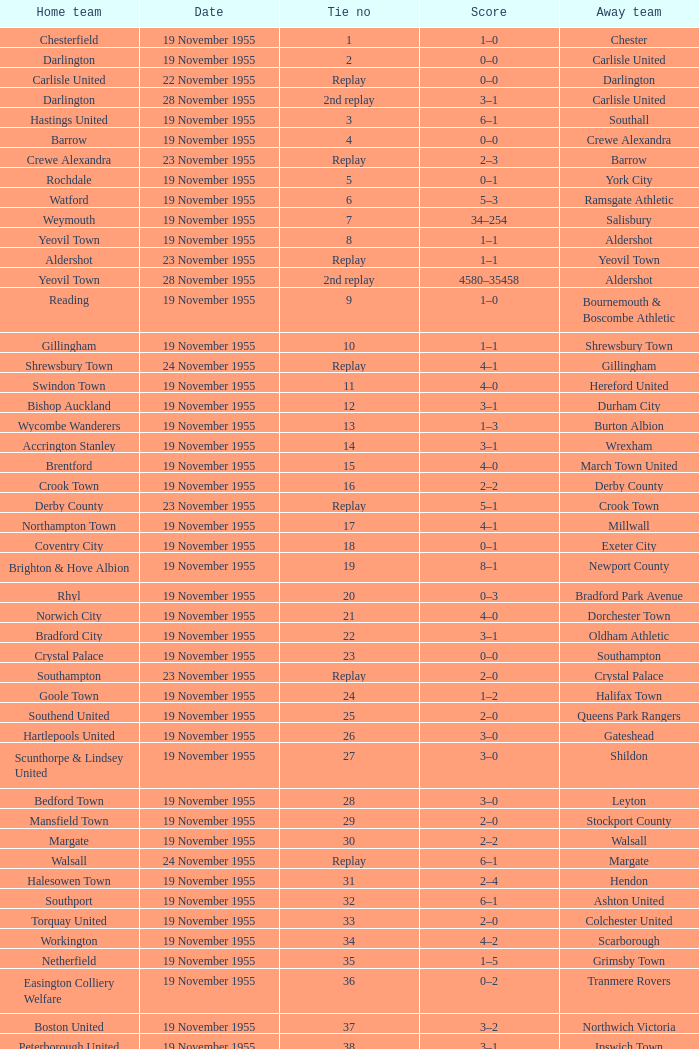Can you parse all the data within this table? {'header': ['Home team', 'Date', 'Tie no', 'Score', 'Away team'], 'rows': [['Chesterfield', '19 November 1955', '1', '1–0', 'Chester'], ['Darlington', '19 November 1955', '2', '0–0', 'Carlisle United'], ['Carlisle United', '22 November 1955', 'Replay', '0–0', 'Darlington'], ['Darlington', '28 November 1955', '2nd replay', '3–1', 'Carlisle United'], ['Hastings United', '19 November 1955', '3', '6–1', 'Southall'], ['Barrow', '19 November 1955', '4', '0–0', 'Crewe Alexandra'], ['Crewe Alexandra', '23 November 1955', 'Replay', '2–3', 'Barrow'], ['Rochdale', '19 November 1955', '5', '0–1', 'York City'], ['Watford', '19 November 1955', '6', '5–3', 'Ramsgate Athletic'], ['Weymouth', '19 November 1955', '7', '34–254', 'Salisbury'], ['Yeovil Town', '19 November 1955', '8', '1–1', 'Aldershot'], ['Aldershot', '23 November 1955', 'Replay', '1–1', 'Yeovil Town'], ['Yeovil Town', '28 November 1955', '2nd replay', '4580–35458', 'Aldershot'], ['Reading', '19 November 1955', '9', '1–0', 'Bournemouth & Boscombe Athletic'], ['Gillingham', '19 November 1955', '10', '1–1', 'Shrewsbury Town'], ['Shrewsbury Town', '24 November 1955', 'Replay', '4–1', 'Gillingham'], ['Swindon Town', '19 November 1955', '11', '4–0', 'Hereford United'], ['Bishop Auckland', '19 November 1955', '12', '3–1', 'Durham City'], ['Wycombe Wanderers', '19 November 1955', '13', '1–3', 'Burton Albion'], ['Accrington Stanley', '19 November 1955', '14', '3–1', 'Wrexham'], ['Brentford', '19 November 1955', '15', '4–0', 'March Town United'], ['Crook Town', '19 November 1955', '16', '2–2', 'Derby County'], ['Derby County', '23 November 1955', 'Replay', '5–1', 'Crook Town'], ['Northampton Town', '19 November 1955', '17', '4–1', 'Millwall'], ['Coventry City', '19 November 1955', '18', '0–1', 'Exeter City'], ['Brighton & Hove Albion', '19 November 1955', '19', '8–1', 'Newport County'], ['Rhyl', '19 November 1955', '20', '0–3', 'Bradford Park Avenue'], ['Norwich City', '19 November 1955', '21', '4–0', 'Dorchester Town'], ['Bradford City', '19 November 1955', '22', '3–1', 'Oldham Athletic'], ['Crystal Palace', '19 November 1955', '23', '0–0', 'Southampton'], ['Southampton', '23 November 1955', 'Replay', '2–0', 'Crystal Palace'], ['Goole Town', '19 November 1955', '24', '1–2', 'Halifax Town'], ['Southend United', '19 November 1955', '25', '2–0', 'Queens Park Rangers'], ['Hartlepools United', '19 November 1955', '26', '3–0', 'Gateshead'], ['Scunthorpe & Lindsey United', '19 November 1955', '27', '3–0', 'Shildon'], ['Bedford Town', '19 November 1955', '28', '3–0', 'Leyton'], ['Mansfield Town', '19 November 1955', '29', '2–0', 'Stockport County'], ['Margate', '19 November 1955', '30', '2–2', 'Walsall'], ['Walsall', '24 November 1955', 'Replay', '6–1', 'Margate'], ['Halesowen Town', '19 November 1955', '31', '2–4', 'Hendon'], ['Southport', '19 November 1955', '32', '6–1', 'Ashton United'], ['Torquay United', '19 November 1955', '33', '2–0', 'Colchester United'], ['Workington', '19 November 1955', '34', '4–2', 'Scarborough'], ['Netherfield', '19 November 1955', '35', '1–5', 'Grimsby Town'], ['Easington Colliery Welfare', '19 November 1955', '36', '0–2', 'Tranmere Rovers'], ['Boston United', '19 November 1955', '37', '3–2', 'Northwich Victoria'], ['Peterborough United', '19 November 1955', '38', '3–1', 'Ipswich Town'], ['Leyton Orient', '19 November 1955', '39', '7–1', 'Lovells Athletic'], ['Skegness Town', '19 November 1955', '40', '0–4', 'Worksop Town']]} What is the home team with scarborough as the away team? Workington. 